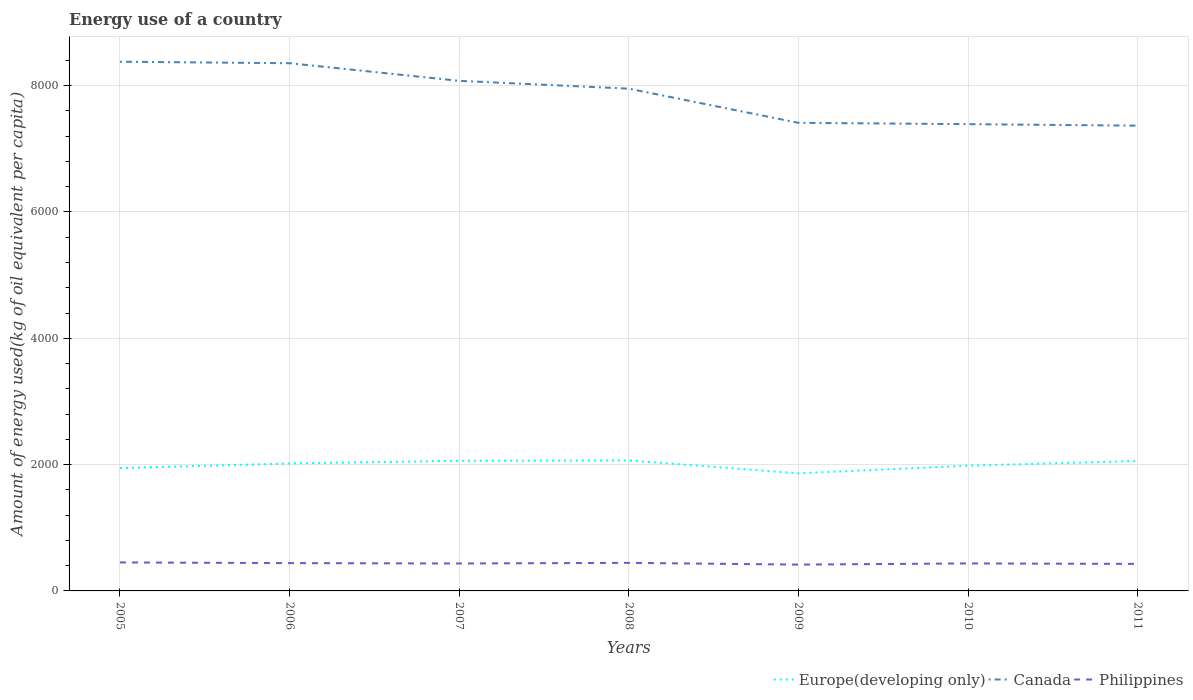How many different coloured lines are there?
Make the answer very short. 3. Is the number of lines equal to the number of legend labels?
Offer a very short reply. Yes. Across all years, what is the maximum amount of energy used in in Canada?
Offer a very short reply. 7366.64. What is the total amount of energy used in in Europe(developing only) in the graph?
Make the answer very short. 34.74. What is the difference between the highest and the second highest amount of energy used in in Canada?
Keep it short and to the point. 1012.19. What is the difference between the highest and the lowest amount of energy used in in Philippines?
Provide a short and direct response. 3. Is the amount of energy used in in Philippines strictly greater than the amount of energy used in in Europe(developing only) over the years?
Ensure brevity in your answer.  Yes. Are the values on the major ticks of Y-axis written in scientific E-notation?
Provide a succinct answer. No. Does the graph contain any zero values?
Make the answer very short. No. Where does the legend appear in the graph?
Keep it short and to the point. Bottom right. How many legend labels are there?
Provide a short and direct response. 3. What is the title of the graph?
Your answer should be compact. Energy use of a country. Does "Switzerland" appear as one of the legend labels in the graph?
Your answer should be compact. No. What is the label or title of the Y-axis?
Your answer should be compact. Amount of energy used(kg of oil equivalent per capita). What is the Amount of energy used(kg of oil equivalent per capita) in Europe(developing only) in 2005?
Offer a terse response. 1944.76. What is the Amount of energy used(kg of oil equivalent per capita) of Canada in 2005?
Your answer should be compact. 8378.83. What is the Amount of energy used(kg of oil equivalent per capita) in Philippines in 2005?
Ensure brevity in your answer.  451.04. What is the Amount of energy used(kg of oil equivalent per capita) of Europe(developing only) in 2006?
Provide a short and direct response. 2017.58. What is the Amount of energy used(kg of oil equivalent per capita) in Canada in 2006?
Ensure brevity in your answer.  8355.17. What is the Amount of energy used(kg of oil equivalent per capita) in Philippines in 2006?
Offer a very short reply. 440.33. What is the Amount of energy used(kg of oil equivalent per capita) of Europe(developing only) in 2007?
Provide a short and direct response. 2060.29. What is the Amount of energy used(kg of oil equivalent per capita) of Canada in 2007?
Offer a terse response. 8076.4. What is the Amount of energy used(kg of oil equivalent per capita) of Philippines in 2007?
Give a very brief answer. 434.4. What is the Amount of energy used(kg of oil equivalent per capita) in Europe(developing only) in 2008?
Offer a very short reply. 2066.27. What is the Amount of energy used(kg of oil equivalent per capita) of Canada in 2008?
Make the answer very short. 7952.21. What is the Amount of energy used(kg of oil equivalent per capita) of Philippines in 2008?
Make the answer very short. 444.15. What is the Amount of energy used(kg of oil equivalent per capita) of Europe(developing only) in 2009?
Your response must be concise. 1862.01. What is the Amount of energy used(kg of oil equivalent per capita) in Canada in 2009?
Ensure brevity in your answer.  7411.42. What is the Amount of energy used(kg of oil equivalent per capita) in Philippines in 2009?
Make the answer very short. 416.69. What is the Amount of energy used(kg of oil equivalent per capita) of Europe(developing only) in 2010?
Ensure brevity in your answer.  1982.83. What is the Amount of energy used(kg of oil equivalent per capita) of Canada in 2010?
Make the answer very short. 7390.37. What is the Amount of energy used(kg of oil equivalent per capita) in Philippines in 2010?
Your response must be concise. 435.28. What is the Amount of energy used(kg of oil equivalent per capita) in Europe(developing only) in 2011?
Make the answer very short. 2056.94. What is the Amount of energy used(kg of oil equivalent per capita) of Canada in 2011?
Offer a very short reply. 7366.64. What is the Amount of energy used(kg of oil equivalent per capita) in Philippines in 2011?
Give a very brief answer. 428. Across all years, what is the maximum Amount of energy used(kg of oil equivalent per capita) in Europe(developing only)?
Offer a terse response. 2066.27. Across all years, what is the maximum Amount of energy used(kg of oil equivalent per capita) in Canada?
Provide a short and direct response. 8378.83. Across all years, what is the maximum Amount of energy used(kg of oil equivalent per capita) of Philippines?
Provide a short and direct response. 451.04. Across all years, what is the minimum Amount of energy used(kg of oil equivalent per capita) of Europe(developing only)?
Make the answer very short. 1862.01. Across all years, what is the minimum Amount of energy used(kg of oil equivalent per capita) in Canada?
Your answer should be very brief. 7366.64. Across all years, what is the minimum Amount of energy used(kg of oil equivalent per capita) of Philippines?
Keep it short and to the point. 416.69. What is the total Amount of energy used(kg of oil equivalent per capita) in Europe(developing only) in the graph?
Offer a very short reply. 1.40e+04. What is the total Amount of energy used(kg of oil equivalent per capita) of Canada in the graph?
Your answer should be very brief. 5.49e+04. What is the total Amount of energy used(kg of oil equivalent per capita) in Philippines in the graph?
Your answer should be very brief. 3049.89. What is the difference between the Amount of energy used(kg of oil equivalent per capita) of Europe(developing only) in 2005 and that in 2006?
Your answer should be very brief. -72.82. What is the difference between the Amount of energy used(kg of oil equivalent per capita) in Canada in 2005 and that in 2006?
Your answer should be very brief. 23.66. What is the difference between the Amount of energy used(kg of oil equivalent per capita) of Philippines in 2005 and that in 2006?
Your answer should be compact. 10.72. What is the difference between the Amount of energy used(kg of oil equivalent per capita) of Europe(developing only) in 2005 and that in 2007?
Give a very brief answer. -115.53. What is the difference between the Amount of energy used(kg of oil equivalent per capita) in Canada in 2005 and that in 2007?
Offer a very short reply. 302.43. What is the difference between the Amount of energy used(kg of oil equivalent per capita) in Philippines in 2005 and that in 2007?
Your answer should be compact. 16.64. What is the difference between the Amount of energy used(kg of oil equivalent per capita) in Europe(developing only) in 2005 and that in 2008?
Your answer should be compact. -121.51. What is the difference between the Amount of energy used(kg of oil equivalent per capita) in Canada in 2005 and that in 2008?
Your answer should be compact. 426.61. What is the difference between the Amount of energy used(kg of oil equivalent per capita) in Philippines in 2005 and that in 2008?
Keep it short and to the point. 6.9. What is the difference between the Amount of energy used(kg of oil equivalent per capita) in Europe(developing only) in 2005 and that in 2009?
Give a very brief answer. 82.74. What is the difference between the Amount of energy used(kg of oil equivalent per capita) in Canada in 2005 and that in 2009?
Provide a succinct answer. 967.41. What is the difference between the Amount of energy used(kg of oil equivalent per capita) in Philippines in 2005 and that in 2009?
Provide a succinct answer. 34.35. What is the difference between the Amount of energy used(kg of oil equivalent per capita) of Europe(developing only) in 2005 and that in 2010?
Offer a very short reply. -38.08. What is the difference between the Amount of energy used(kg of oil equivalent per capita) in Canada in 2005 and that in 2010?
Give a very brief answer. 988.46. What is the difference between the Amount of energy used(kg of oil equivalent per capita) of Philippines in 2005 and that in 2010?
Make the answer very short. 15.77. What is the difference between the Amount of energy used(kg of oil equivalent per capita) in Europe(developing only) in 2005 and that in 2011?
Your response must be concise. -112.19. What is the difference between the Amount of energy used(kg of oil equivalent per capita) of Canada in 2005 and that in 2011?
Make the answer very short. 1012.19. What is the difference between the Amount of energy used(kg of oil equivalent per capita) in Philippines in 2005 and that in 2011?
Ensure brevity in your answer.  23.05. What is the difference between the Amount of energy used(kg of oil equivalent per capita) in Europe(developing only) in 2006 and that in 2007?
Offer a terse response. -42.71. What is the difference between the Amount of energy used(kg of oil equivalent per capita) of Canada in 2006 and that in 2007?
Offer a terse response. 278.78. What is the difference between the Amount of energy used(kg of oil equivalent per capita) in Philippines in 2006 and that in 2007?
Offer a terse response. 5.92. What is the difference between the Amount of energy used(kg of oil equivalent per capita) in Europe(developing only) in 2006 and that in 2008?
Make the answer very short. -48.69. What is the difference between the Amount of energy used(kg of oil equivalent per capita) of Canada in 2006 and that in 2008?
Provide a short and direct response. 402.96. What is the difference between the Amount of energy used(kg of oil equivalent per capita) of Philippines in 2006 and that in 2008?
Offer a terse response. -3.82. What is the difference between the Amount of energy used(kg of oil equivalent per capita) of Europe(developing only) in 2006 and that in 2009?
Keep it short and to the point. 155.57. What is the difference between the Amount of energy used(kg of oil equivalent per capita) of Canada in 2006 and that in 2009?
Give a very brief answer. 943.75. What is the difference between the Amount of energy used(kg of oil equivalent per capita) of Philippines in 2006 and that in 2009?
Your response must be concise. 23.63. What is the difference between the Amount of energy used(kg of oil equivalent per capita) of Europe(developing only) in 2006 and that in 2010?
Offer a very short reply. 34.74. What is the difference between the Amount of energy used(kg of oil equivalent per capita) of Canada in 2006 and that in 2010?
Make the answer very short. 964.8. What is the difference between the Amount of energy used(kg of oil equivalent per capita) of Philippines in 2006 and that in 2010?
Give a very brief answer. 5.05. What is the difference between the Amount of energy used(kg of oil equivalent per capita) of Europe(developing only) in 2006 and that in 2011?
Your response must be concise. -39.37. What is the difference between the Amount of energy used(kg of oil equivalent per capita) of Canada in 2006 and that in 2011?
Offer a terse response. 988.53. What is the difference between the Amount of energy used(kg of oil equivalent per capita) of Philippines in 2006 and that in 2011?
Your response must be concise. 12.33. What is the difference between the Amount of energy used(kg of oil equivalent per capita) in Europe(developing only) in 2007 and that in 2008?
Offer a very short reply. -5.98. What is the difference between the Amount of energy used(kg of oil equivalent per capita) in Canada in 2007 and that in 2008?
Provide a succinct answer. 124.18. What is the difference between the Amount of energy used(kg of oil equivalent per capita) of Philippines in 2007 and that in 2008?
Your answer should be very brief. -9.74. What is the difference between the Amount of energy used(kg of oil equivalent per capita) of Europe(developing only) in 2007 and that in 2009?
Offer a terse response. 198.28. What is the difference between the Amount of energy used(kg of oil equivalent per capita) in Canada in 2007 and that in 2009?
Your answer should be compact. 664.98. What is the difference between the Amount of energy used(kg of oil equivalent per capita) of Philippines in 2007 and that in 2009?
Make the answer very short. 17.71. What is the difference between the Amount of energy used(kg of oil equivalent per capita) in Europe(developing only) in 2007 and that in 2010?
Offer a very short reply. 77.45. What is the difference between the Amount of energy used(kg of oil equivalent per capita) of Canada in 2007 and that in 2010?
Your answer should be very brief. 686.02. What is the difference between the Amount of energy used(kg of oil equivalent per capita) of Philippines in 2007 and that in 2010?
Offer a terse response. -0.88. What is the difference between the Amount of energy used(kg of oil equivalent per capita) in Europe(developing only) in 2007 and that in 2011?
Your response must be concise. 3.35. What is the difference between the Amount of energy used(kg of oil equivalent per capita) of Canada in 2007 and that in 2011?
Make the answer very short. 709.76. What is the difference between the Amount of energy used(kg of oil equivalent per capita) of Philippines in 2007 and that in 2011?
Give a very brief answer. 6.41. What is the difference between the Amount of energy used(kg of oil equivalent per capita) in Europe(developing only) in 2008 and that in 2009?
Provide a short and direct response. 204.26. What is the difference between the Amount of energy used(kg of oil equivalent per capita) of Canada in 2008 and that in 2009?
Keep it short and to the point. 540.79. What is the difference between the Amount of energy used(kg of oil equivalent per capita) in Philippines in 2008 and that in 2009?
Offer a terse response. 27.45. What is the difference between the Amount of energy used(kg of oil equivalent per capita) in Europe(developing only) in 2008 and that in 2010?
Make the answer very short. 83.43. What is the difference between the Amount of energy used(kg of oil equivalent per capita) of Canada in 2008 and that in 2010?
Offer a very short reply. 561.84. What is the difference between the Amount of energy used(kg of oil equivalent per capita) in Philippines in 2008 and that in 2010?
Your answer should be compact. 8.87. What is the difference between the Amount of energy used(kg of oil equivalent per capita) in Europe(developing only) in 2008 and that in 2011?
Keep it short and to the point. 9.32. What is the difference between the Amount of energy used(kg of oil equivalent per capita) of Canada in 2008 and that in 2011?
Give a very brief answer. 585.57. What is the difference between the Amount of energy used(kg of oil equivalent per capita) of Philippines in 2008 and that in 2011?
Provide a succinct answer. 16.15. What is the difference between the Amount of energy used(kg of oil equivalent per capita) of Europe(developing only) in 2009 and that in 2010?
Ensure brevity in your answer.  -120.82. What is the difference between the Amount of energy used(kg of oil equivalent per capita) in Canada in 2009 and that in 2010?
Provide a succinct answer. 21.05. What is the difference between the Amount of energy used(kg of oil equivalent per capita) in Philippines in 2009 and that in 2010?
Give a very brief answer. -18.58. What is the difference between the Amount of energy used(kg of oil equivalent per capita) of Europe(developing only) in 2009 and that in 2011?
Keep it short and to the point. -194.93. What is the difference between the Amount of energy used(kg of oil equivalent per capita) in Canada in 2009 and that in 2011?
Your response must be concise. 44.78. What is the difference between the Amount of energy used(kg of oil equivalent per capita) in Philippines in 2009 and that in 2011?
Your answer should be compact. -11.3. What is the difference between the Amount of energy used(kg of oil equivalent per capita) in Europe(developing only) in 2010 and that in 2011?
Keep it short and to the point. -74.11. What is the difference between the Amount of energy used(kg of oil equivalent per capita) in Canada in 2010 and that in 2011?
Make the answer very short. 23.73. What is the difference between the Amount of energy used(kg of oil equivalent per capita) in Philippines in 2010 and that in 2011?
Offer a very short reply. 7.28. What is the difference between the Amount of energy used(kg of oil equivalent per capita) in Europe(developing only) in 2005 and the Amount of energy used(kg of oil equivalent per capita) in Canada in 2006?
Offer a very short reply. -6410.42. What is the difference between the Amount of energy used(kg of oil equivalent per capita) of Europe(developing only) in 2005 and the Amount of energy used(kg of oil equivalent per capita) of Philippines in 2006?
Provide a short and direct response. 1504.43. What is the difference between the Amount of energy used(kg of oil equivalent per capita) in Canada in 2005 and the Amount of energy used(kg of oil equivalent per capita) in Philippines in 2006?
Provide a succinct answer. 7938.5. What is the difference between the Amount of energy used(kg of oil equivalent per capita) in Europe(developing only) in 2005 and the Amount of energy used(kg of oil equivalent per capita) in Canada in 2007?
Keep it short and to the point. -6131.64. What is the difference between the Amount of energy used(kg of oil equivalent per capita) in Europe(developing only) in 2005 and the Amount of energy used(kg of oil equivalent per capita) in Philippines in 2007?
Your response must be concise. 1510.35. What is the difference between the Amount of energy used(kg of oil equivalent per capita) in Canada in 2005 and the Amount of energy used(kg of oil equivalent per capita) in Philippines in 2007?
Keep it short and to the point. 7944.43. What is the difference between the Amount of energy used(kg of oil equivalent per capita) of Europe(developing only) in 2005 and the Amount of energy used(kg of oil equivalent per capita) of Canada in 2008?
Your answer should be very brief. -6007.46. What is the difference between the Amount of energy used(kg of oil equivalent per capita) in Europe(developing only) in 2005 and the Amount of energy used(kg of oil equivalent per capita) in Philippines in 2008?
Offer a terse response. 1500.61. What is the difference between the Amount of energy used(kg of oil equivalent per capita) in Canada in 2005 and the Amount of energy used(kg of oil equivalent per capita) in Philippines in 2008?
Your answer should be compact. 7934.68. What is the difference between the Amount of energy used(kg of oil equivalent per capita) in Europe(developing only) in 2005 and the Amount of energy used(kg of oil equivalent per capita) in Canada in 2009?
Keep it short and to the point. -5466.66. What is the difference between the Amount of energy used(kg of oil equivalent per capita) in Europe(developing only) in 2005 and the Amount of energy used(kg of oil equivalent per capita) in Philippines in 2009?
Provide a short and direct response. 1528.06. What is the difference between the Amount of energy used(kg of oil equivalent per capita) of Canada in 2005 and the Amount of energy used(kg of oil equivalent per capita) of Philippines in 2009?
Provide a succinct answer. 7962.13. What is the difference between the Amount of energy used(kg of oil equivalent per capita) of Europe(developing only) in 2005 and the Amount of energy used(kg of oil equivalent per capita) of Canada in 2010?
Ensure brevity in your answer.  -5445.62. What is the difference between the Amount of energy used(kg of oil equivalent per capita) in Europe(developing only) in 2005 and the Amount of energy used(kg of oil equivalent per capita) in Philippines in 2010?
Your answer should be compact. 1509.48. What is the difference between the Amount of energy used(kg of oil equivalent per capita) in Canada in 2005 and the Amount of energy used(kg of oil equivalent per capita) in Philippines in 2010?
Make the answer very short. 7943.55. What is the difference between the Amount of energy used(kg of oil equivalent per capita) in Europe(developing only) in 2005 and the Amount of energy used(kg of oil equivalent per capita) in Canada in 2011?
Provide a short and direct response. -5421.88. What is the difference between the Amount of energy used(kg of oil equivalent per capita) of Europe(developing only) in 2005 and the Amount of energy used(kg of oil equivalent per capita) of Philippines in 2011?
Keep it short and to the point. 1516.76. What is the difference between the Amount of energy used(kg of oil equivalent per capita) of Canada in 2005 and the Amount of energy used(kg of oil equivalent per capita) of Philippines in 2011?
Your answer should be very brief. 7950.83. What is the difference between the Amount of energy used(kg of oil equivalent per capita) in Europe(developing only) in 2006 and the Amount of energy used(kg of oil equivalent per capita) in Canada in 2007?
Make the answer very short. -6058.82. What is the difference between the Amount of energy used(kg of oil equivalent per capita) in Europe(developing only) in 2006 and the Amount of energy used(kg of oil equivalent per capita) in Philippines in 2007?
Make the answer very short. 1583.17. What is the difference between the Amount of energy used(kg of oil equivalent per capita) in Canada in 2006 and the Amount of energy used(kg of oil equivalent per capita) in Philippines in 2007?
Keep it short and to the point. 7920.77. What is the difference between the Amount of energy used(kg of oil equivalent per capita) in Europe(developing only) in 2006 and the Amount of energy used(kg of oil equivalent per capita) in Canada in 2008?
Offer a very short reply. -5934.64. What is the difference between the Amount of energy used(kg of oil equivalent per capita) in Europe(developing only) in 2006 and the Amount of energy used(kg of oil equivalent per capita) in Philippines in 2008?
Make the answer very short. 1573.43. What is the difference between the Amount of energy used(kg of oil equivalent per capita) in Canada in 2006 and the Amount of energy used(kg of oil equivalent per capita) in Philippines in 2008?
Provide a succinct answer. 7911.03. What is the difference between the Amount of energy used(kg of oil equivalent per capita) of Europe(developing only) in 2006 and the Amount of energy used(kg of oil equivalent per capita) of Canada in 2009?
Ensure brevity in your answer.  -5393.84. What is the difference between the Amount of energy used(kg of oil equivalent per capita) of Europe(developing only) in 2006 and the Amount of energy used(kg of oil equivalent per capita) of Philippines in 2009?
Offer a very short reply. 1600.88. What is the difference between the Amount of energy used(kg of oil equivalent per capita) in Canada in 2006 and the Amount of energy used(kg of oil equivalent per capita) in Philippines in 2009?
Offer a terse response. 7938.48. What is the difference between the Amount of energy used(kg of oil equivalent per capita) of Europe(developing only) in 2006 and the Amount of energy used(kg of oil equivalent per capita) of Canada in 2010?
Provide a short and direct response. -5372.8. What is the difference between the Amount of energy used(kg of oil equivalent per capita) in Europe(developing only) in 2006 and the Amount of energy used(kg of oil equivalent per capita) in Philippines in 2010?
Provide a short and direct response. 1582.3. What is the difference between the Amount of energy used(kg of oil equivalent per capita) in Canada in 2006 and the Amount of energy used(kg of oil equivalent per capita) in Philippines in 2010?
Your answer should be compact. 7919.9. What is the difference between the Amount of energy used(kg of oil equivalent per capita) in Europe(developing only) in 2006 and the Amount of energy used(kg of oil equivalent per capita) in Canada in 2011?
Keep it short and to the point. -5349.06. What is the difference between the Amount of energy used(kg of oil equivalent per capita) in Europe(developing only) in 2006 and the Amount of energy used(kg of oil equivalent per capita) in Philippines in 2011?
Offer a terse response. 1589.58. What is the difference between the Amount of energy used(kg of oil equivalent per capita) of Canada in 2006 and the Amount of energy used(kg of oil equivalent per capita) of Philippines in 2011?
Make the answer very short. 7927.18. What is the difference between the Amount of energy used(kg of oil equivalent per capita) in Europe(developing only) in 2007 and the Amount of energy used(kg of oil equivalent per capita) in Canada in 2008?
Make the answer very short. -5891.92. What is the difference between the Amount of energy used(kg of oil equivalent per capita) in Europe(developing only) in 2007 and the Amount of energy used(kg of oil equivalent per capita) in Philippines in 2008?
Your answer should be compact. 1616.14. What is the difference between the Amount of energy used(kg of oil equivalent per capita) in Canada in 2007 and the Amount of energy used(kg of oil equivalent per capita) in Philippines in 2008?
Make the answer very short. 7632.25. What is the difference between the Amount of energy used(kg of oil equivalent per capita) in Europe(developing only) in 2007 and the Amount of energy used(kg of oil equivalent per capita) in Canada in 2009?
Your answer should be very brief. -5351.13. What is the difference between the Amount of energy used(kg of oil equivalent per capita) in Europe(developing only) in 2007 and the Amount of energy used(kg of oil equivalent per capita) in Philippines in 2009?
Your response must be concise. 1643.6. What is the difference between the Amount of energy used(kg of oil equivalent per capita) in Canada in 2007 and the Amount of energy used(kg of oil equivalent per capita) in Philippines in 2009?
Provide a short and direct response. 7659.7. What is the difference between the Amount of energy used(kg of oil equivalent per capita) of Europe(developing only) in 2007 and the Amount of energy used(kg of oil equivalent per capita) of Canada in 2010?
Make the answer very short. -5330.08. What is the difference between the Amount of energy used(kg of oil equivalent per capita) in Europe(developing only) in 2007 and the Amount of energy used(kg of oil equivalent per capita) in Philippines in 2010?
Make the answer very short. 1625.01. What is the difference between the Amount of energy used(kg of oil equivalent per capita) of Canada in 2007 and the Amount of energy used(kg of oil equivalent per capita) of Philippines in 2010?
Provide a succinct answer. 7641.12. What is the difference between the Amount of energy used(kg of oil equivalent per capita) of Europe(developing only) in 2007 and the Amount of energy used(kg of oil equivalent per capita) of Canada in 2011?
Keep it short and to the point. -5306.35. What is the difference between the Amount of energy used(kg of oil equivalent per capita) of Europe(developing only) in 2007 and the Amount of energy used(kg of oil equivalent per capita) of Philippines in 2011?
Make the answer very short. 1632.29. What is the difference between the Amount of energy used(kg of oil equivalent per capita) in Canada in 2007 and the Amount of energy used(kg of oil equivalent per capita) in Philippines in 2011?
Keep it short and to the point. 7648.4. What is the difference between the Amount of energy used(kg of oil equivalent per capita) in Europe(developing only) in 2008 and the Amount of energy used(kg of oil equivalent per capita) in Canada in 2009?
Keep it short and to the point. -5345.15. What is the difference between the Amount of energy used(kg of oil equivalent per capita) of Europe(developing only) in 2008 and the Amount of energy used(kg of oil equivalent per capita) of Philippines in 2009?
Keep it short and to the point. 1649.57. What is the difference between the Amount of energy used(kg of oil equivalent per capita) in Canada in 2008 and the Amount of energy used(kg of oil equivalent per capita) in Philippines in 2009?
Offer a terse response. 7535.52. What is the difference between the Amount of energy used(kg of oil equivalent per capita) of Europe(developing only) in 2008 and the Amount of energy used(kg of oil equivalent per capita) of Canada in 2010?
Keep it short and to the point. -5324.1. What is the difference between the Amount of energy used(kg of oil equivalent per capita) of Europe(developing only) in 2008 and the Amount of energy used(kg of oil equivalent per capita) of Philippines in 2010?
Make the answer very short. 1630.99. What is the difference between the Amount of energy used(kg of oil equivalent per capita) of Canada in 2008 and the Amount of energy used(kg of oil equivalent per capita) of Philippines in 2010?
Your answer should be compact. 7516.94. What is the difference between the Amount of energy used(kg of oil equivalent per capita) in Europe(developing only) in 2008 and the Amount of energy used(kg of oil equivalent per capita) in Canada in 2011?
Your answer should be very brief. -5300.37. What is the difference between the Amount of energy used(kg of oil equivalent per capita) of Europe(developing only) in 2008 and the Amount of energy used(kg of oil equivalent per capita) of Philippines in 2011?
Provide a succinct answer. 1638.27. What is the difference between the Amount of energy used(kg of oil equivalent per capita) in Canada in 2008 and the Amount of energy used(kg of oil equivalent per capita) in Philippines in 2011?
Provide a short and direct response. 7524.22. What is the difference between the Amount of energy used(kg of oil equivalent per capita) of Europe(developing only) in 2009 and the Amount of energy used(kg of oil equivalent per capita) of Canada in 2010?
Offer a very short reply. -5528.36. What is the difference between the Amount of energy used(kg of oil equivalent per capita) of Europe(developing only) in 2009 and the Amount of energy used(kg of oil equivalent per capita) of Philippines in 2010?
Provide a short and direct response. 1426.73. What is the difference between the Amount of energy used(kg of oil equivalent per capita) in Canada in 2009 and the Amount of energy used(kg of oil equivalent per capita) in Philippines in 2010?
Your answer should be very brief. 6976.14. What is the difference between the Amount of energy used(kg of oil equivalent per capita) of Europe(developing only) in 2009 and the Amount of energy used(kg of oil equivalent per capita) of Canada in 2011?
Your response must be concise. -5504.63. What is the difference between the Amount of energy used(kg of oil equivalent per capita) in Europe(developing only) in 2009 and the Amount of energy used(kg of oil equivalent per capita) in Philippines in 2011?
Offer a terse response. 1434.02. What is the difference between the Amount of energy used(kg of oil equivalent per capita) in Canada in 2009 and the Amount of energy used(kg of oil equivalent per capita) in Philippines in 2011?
Ensure brevity in your answer.  6983.42. What is the difference between the Amount of energy used(kg of oil equivalent per capita) in Europe(developing only) in 2010 and the Amount of energy used(kg of oil equivalent per capita) in Canada in 2011?
Your response must be concise. -5383.81. What is the difference between the Amount of energy used(kg of oil equivalent per capita) of Europe(developing only) in 2010 and the Amount of energy used(kg of oil equivalent per capita) of Philippines in 2011?
Keep it short and to the point. 1554.84. What is the difference between the Amount of energy used(kg of oil equivalent per capita) in Canada in 2010 and the Amount of energy used(kg of oil equivalent per capita) in Philippines in 2011?
Give a very brief answer. 6962.38. What is the average Amount of energy used(kg of oil equivalent per capita) of Europe(developing only) per year?
Your answer should be compact. 1998.67. What is the average Amount of energy used(kg of oil equivalent per capita) of Canada per year?
Make the answer very short. 7847.29. What is the average Amount of energy used(kg of oil equivalent per capita) of Philippines per year?
Your answer should be very brief. 435.7. In the year 2005, what is the difference between the Amount of energy used(kg of oil equivalent per capita) in Europe(developing only) and Amount of energy used(kg of oil equivalent per capita) in Canada?
Offer a very short reply. -6434.07. In the year 2005, what is the difference between the Amount of energy used(kg of oil equivalent per capita) in Europe(developing only) and Amount of energy used(kg of oil equivalent per capita) in Philippines?
Your answer should be compact. 1493.71. In the year 2005, what is the difference between the Amount of energy used(kg of oil equivalent per capita) of Canada and Amount of energy used(kg of oil equivalent per capita) of Philippines?
Your answer should be very brief. 7927.78. In the year 2006, what is the difference between the Amount of energy used(kg of oil equivalent per capita) in Europe(developing only) and Amount of energy used(kg of oil equivalent per capita) in Canada?
Provide a short and direct response. -6337.6. In the year 2006, what is the difference between the Amount of energy used(kg of oil equivalent per capita) of Europe(developing only) and Amount of energy used(kg of oil equivalent per capita) of Philippines?
Offer a very short reply. 1577.25. In the year 2006, what is the difference between the Amount of energy used(kg of oil equivalent per capita) in Canada and Amount of energy used(kg of oil equivalent per capita) in Philippines?
Offer a terse response. 7914.85. In the year 2007, what is the difference between the Amount of energy used(kg of oil equivalent per capita) of Europe(developing only) and Amount of energy used(kg of oil equivalent per capita) of Canada?
Give a very brief answer. -6016.11. In the year 2007, what is the difference between the Amount of energy used(kg of oil equivalent per capita) in Europe(developing only) and Amount of energy used(kg of oil equivalent per capita) in Philippines?
Your answer should be compact. 1625.89. In the year 2007, what is the difference between the Amount of energy used(kg of oil equivalent per capita) in Canada and Amount of energy used(kg of oil equivalent per capita) in Philippines?
Offer a very short reply. 7642. In the year 2008, what is the difference between the Amount of energy used(kg of oil equivalent per capita) in Europe(developing only) and Amount of energy used(kg of oil equivalent per capita) in Canada?
Ensure brevity in your answer.  -5885.95. In the year 2008, what is the difference between the Amount of energy used(kg of oil equivalent per capita) in Europe(developing only) and Amount of energy used(kg of oil equivalent per capita) in Philippines?
Your answer should be compact. 1622.12. In the year 2008, what is the difference between the Amount of energy used(kg of oil equivalent per capita) in Canada and Amount of energy used(kg of oil equivalent per capita) in Philippines?
Offer a very short reply. 7508.07. In the year 2009, what is the difference between the Amount of energy used(kg of oil equivalent per capita) of Europe(developing only) and Amount of energy used(kg of oil equivalent per capita) of Canada?
Your response must be concise. -5549.41. In the year 2009, what is the difference between the Amount of energy used(kg of oil equivalent per capita) of Europe(developing only) and Amount of energy used(kg of oil equivalent per capita) of Philippines?
Give a very brief answer. 1445.32. In the year 2009, what is the difference between the Amount of energy used(kg of oil equivalent per capita) in Canada and Amount of energy used(kg of oil equivalent per capita) in Philippines?
Offer a very short reply. 6994.73. In the year 2010, what is the difference between the Amount of energy used(kg of oil equivalent per capita) of Europe(developing only) and Amount of energy used(kg of oil equivalent per capita) of Canada?
Offer a very short reply. -5407.54. In the year 2010, what is the difference between the Amount of energy used(kg of oil equivalent per capita) in Europe(developing only) and Amount of energy used(kg of oil equivalent per capita) in Philippines?
Provide a succinct answer. 1547.56. In the year 2010, what is the difference between the Amount of energy used(kg of oil equivalent per capita) of Canada and Amount of energy used(kg of oil equivalent per capita) of Philippines?
Your answer should be compact. 6955.1. In the year 2011, what is the difference between the Amount of energy used(kg of oil equivalent per capita) of Europe(developing only) and Amount of energy used(kg of oil equivalent per capita) of Canada?
Your answer should be very brief. -5309.7. In the year 2011, what is the difference between the Amount of energy used(kg of oil equivalent per capita) in Europe(developing only) and Amount of energy used(kg of oil equivalent per capita) in Philippines?
Offer a terse response. 1628.95. In the year 2011, what is the difference between the Amount of energy used(kg of oil equivalent per capita) of Canada and Amount of energy used(kg of oil equivalent per capita) of Philippines?
Ensure brevity in your answer.  6938.64. What is the ratio of the Amount of energy used(kg of oil equivalent per capita) in Europe(developing only) in 2005 to that in 2006?
Your answer should be very brief. 0.96. What is the ratio of the Amount of energy used(kg of oil equivalent per capita) of Philippines in 2005 to that in 2006?
Keep it short and to the point. 1.02. What is the ratio of the Amount of energy used(kg of oil equivalent per capita) of Europe(developing only) in 2005 to that in 2007?
Provide a succinct answer. 0.94. What is the ratio of the Amount of energy used(kg of oil equivalent per capita) of Canada in 2005 to that in 2007?
Provide a succinct answer. 1.04. What is the ratio of the Amount of energy used(kg of oil equivalent per capita) of Philippines in 2005 to that in 2007?
Provide a succinct answer. 1.04. What is the ratio of the Amount of energy used(kg of oil equivalent per capita) of Europe(developing only) in 2005 to that in 2008?
Provide a short and direct response. 0.94. What is the ratio of the Amount of energy used(kg of oil equivalent per capita) of Canada in 2005 to that in 2008?
Offer a very short reply. 1.05. What is the ratio of the Amount of energy used(kg of oil equivalent per capita) of Philippines in 2005 to that in 2008?
Your response must be concise. 1.02. What is the ratio of the Amount of energy used(kg of oil equivalent per capita) in Europe(developing only) in 2005 to that in 2009?
Make the answer very short. 1.04. What is the ratio of the Amount of energy used(kg of oil equivalent per capita) of Canada in 2005 to that in 2009?
Offer a terse response. 1.13. What is the ratio of the Amount of energy used(kg of oil equivalent per capita) of Philippines in 2005 to that in 2009?
Provide a succinct answer. 1.08. What is the ratio of the Amount of energy used(kg of oil equivalent per capita) of Europe(developing only) in 2005 to that in 2010?
Your response must be concise. 0.98. What is the ratio of the Amount of energy used(kg of oil equivalent per capita) in Canada in 2005 to that in 2010?
Offer a terse response. 1.13. What is the ratio of the Amount of energy used(kg of oil equivalent per capita) in Philippines in 2005 to that in 2010?
Make the answer very short. 1.04. What is the ratio of the Amount of energy used(kg of oil equivalent per capita) in Europe(developing only) in 2005 to that in 2011?
Keep it short and to the point. 0.95. What is the ratio of the Amount of energy used(kg of oil equivalent per capita) in Canada in 2005 to that in 2011?
Offer a very short reply. 1.14. What is the ratio of the Amount of energy used(kg of oil equivalent per capita) of Philippines in 2005 to that in 2011?
Provide a succinct answer. 1.05. What is the ratio of the Amount of energy used(kg of oil equivalent per capita) of Europe(developing only) in 2006 to that in 2007?
Make the answer very short. 0.98. What is the ratio of the Amount of energy used(kg of oil equivalent per capita) of Canada in 2006 to that in 2007?
Your answer should be compact. 1.03. What is the ratio of the Amount of energy used(kg of oil equivalent per capita) of Philippines in 2006 to that in 2007?
Your answer should be compact. 1.01. What is the ratio of the Amount of energy used(kg of oil equivalent per capita) in Europe(developing only) in 2006 to that in 2008?
Make the answer very short. 0.98. What is the ratio of the Amount of energy used(kg of oil equivalent per capita) of Canada in 2006 to that in 2008?
Give a very brief answer. 1.05. What is the ratio of the Amount of energy used(kg of oil equivalent per capita) of Europe(developing only) in 2006 to that in 2009?
Give a very brief answer. 1.08. What is the ratio of the Amount of energy used(kg of oil equivalent per capita) in Canada in 2006 to that in 2009?
Provide a succinct answer. 1.13. What is the ratio of the Amount of energy used(kg of oil equivalent per capita) in Philippines in 2006 to that in 2009?
Your response must be concise. 1.06. What is the ratio of the Amount of energy used(kg of oil equivalent per capita) in Europe(developing only) in 2006 to that in 2010?
Your answer should be very brief. 1.02. What is the ratio of the Amount of energy used(kg of oil equivalent per capita) in Canada in 2006 to that in 2010?
Provide a succinct answer. 1.13. What is the ratio of the Amount of energy used(kg of oil equivalent per capita) of Philippines in 2006 to that in 2010?
Ensure brevity in your answer.  1.01. What is the ratio of the Amount of energy used(kg of oil equivalent per capita) in Europe(developing only) in 2006 to that in 2011?
Offer a terse response. 0.98. What is the ratio of the Amount of energy used(kg of oil equivalent per capita) in Canada in 2006 to that in 2011?
Your answer should be very brief. 1.13. What is the ratio of the Amount of energy used(kg of oil equivalent per capita) in Philippines in 2006 to that in 2011?
Give a very brief answer. 1.03. What is the ratio of the Amount of energy used(kg of oil equivalent per capita) of Canada in 2007 to that in 2008?
Offer a terse response. 1.02. What is the ratio of the Amount of energy used(kg of oil equivalent per capita) of Philippines in 2007 to that in 2008?
Provide a short and direct response. 0.98. What is the ratio of the Amount of energy used(kg of oil equivalent per capita) in Europe(developing only) in 2007 to that in 2009?
Make the answer very short. 1.11. What is the ratio of the Amount of energy used(kg of oil equivalent per capita) of Canada in 2007 to that in 2009?
Offer a terse response. 1.09. What is the ratio of the Amount of energy used(kg of oil equivalent per capita) of Philippines in 2007 to that in 2009?
Your answer should be very brief. 1.04. What is the ratio of the Amount of energy used(kg of oil equivalent per capita) in Europe(developing only) in 2007 to that in 2010?
Provide a succinct answer. 1.04. What is the ratio of the Amount of energy used(kg of oil equivalent per capita) of Canada in 2007 to that in 2010?
Ensure brevity in your answer.  1.09. What is the ratio of the Amount of energy used(kg of oil equivalent per capita) in Philippines in 2007 to that in 2010?
Provide a succinct answer. 1. What is the ratio of the Amount of energy used(kg of oil equivalent per capita) in Canada in 2007 to that in 2011?
Your response must be concise. 1.1. What is the ratio of the Amount of energy used(kg of oil equivalent per capita) of Europe(developing only) in 2008 to that in 2009?
Ensure brevity in your answer.  1.11. What is the ratio of the Amount of energy used(kg of oil equivalent per capita) in Canada in 2008 to that in 2009?
Give a very brief answer. 1.07. What is the ratio of the Amount of energy used(kg of oil equivalent per capita) in Philippines in 2008 to that in 2009?
Ensure brevity in your answer.  1.07. What is the ratio of the Amount of energy used(kg of oil equivalent per capita) in Europe(developing only) in 2008 to that in 2010?
Offer a terse response. 1.04. What is the ratio of the Amount of energy used(kg of oil equivalent per capita) in Canada in 2008 to that in 2010?
Provide a short and direct response. 1.08. What is the ratio of the Amount of energy used(kg of oil equivalent per capita) of Philippines in 2008 to that in 2010?
Give a very brief answer. 1.02. What is the ratio of the Amount of energy used(kg of oil equivalent per capita) of Canada in 2008 to that in 2011?
Provide a short and direct response. 1.08. What is the ratio of the Amount of energy used(kg of oil equivalent per capita) of Philippines in 2008 to that in 2011?
Provide a short and direct response. 1.04. What is the ratio of the Amount of energy used(kg of oil equivalent per capita) in Europe(developing only) in 2009 to that in 2010?
Your response must be concise. 0.94. What is the ratio of the Amount of energy used(kg of oil equivalent per capita) in Canada in 2009 to that in 2010?
Give a very brief answer. 1. What is the ratio of the Amount of energy used(kg of oil equivalent per capita) in Philippines in 2009 to that in 2010?
Your answer should be very brief. 0.96. What is the ratio of the Amount of energy used(kg of oil equivalent per capita) of Europe(developing only) in 2009 to that in 2011?
Provide a succinct answer. 0.91. What is the ratio of the Amount of energy used(kg of oil equivalent per capita) in Canada in 2009 to that in 2011?
Your response must be concise. 1.01. What is the ratio of the Amount of energy used(kg of oil equivalent per capita) in Philippines in 2009 to that in 2011?
Your answer should be compact. 0.97. What is the difference between the highest and the second highest Amount of energy used(kg of oil equivalent per capita) of Europe(developing only)?
Offer a very short reply. 5.98. What is the difference between the highest and the second highest Amount of energy used(kg of oil equivalent per capita) of Canada?
Your response must be concise. 23.66. What is the difference between the highest and the second highest Amount of energy used(kg of oil equivalent per capita) of Philippines?
Your response must be concise. 6.9. What is the difference between the highest and the lowest Amount of energy used(kg of oil equivalent per capita) in Europe(developing only)?
Offer a very short reply. 204.26. What is the difference between the highest and the lowest Amount of energy used(kg of oil equivalent per capita) in Canada?
Ensure brevity in your answer.  1012.19. What is the difference between the highest and the lowest Amount of energy used(kg of oil equivalent per capita) in Philippines?
Offer a very short reply. 34.35. 